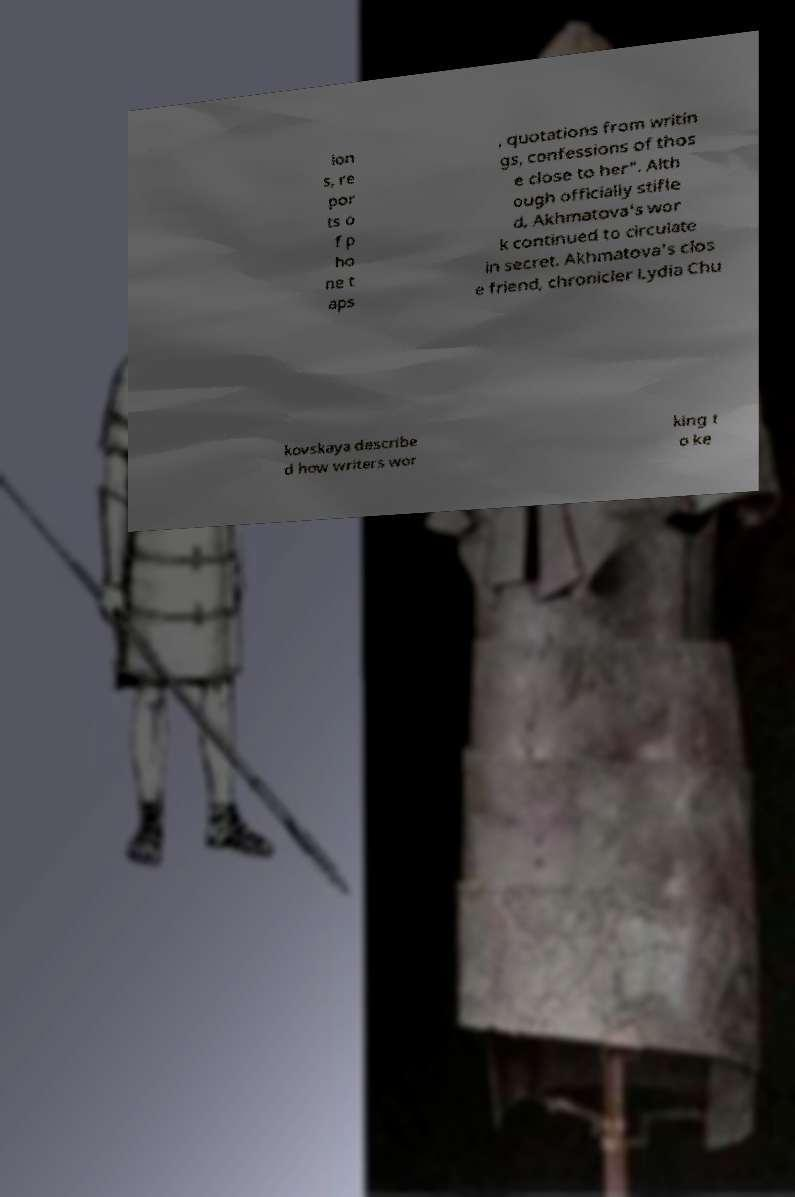For documentation purposes, I need the text within this image transcribed. Could you provide that? ion s, re por ts o f p ho ne t aps , quotations from writin gs, confessions of thos e close to her". Alth ough officially stifle d, Akhmatova's wor k continued to circulate in secret. Akhmatova's clos e friend, chronicler Lydia Chu kovskaya describe d how writers wor king t o ke 